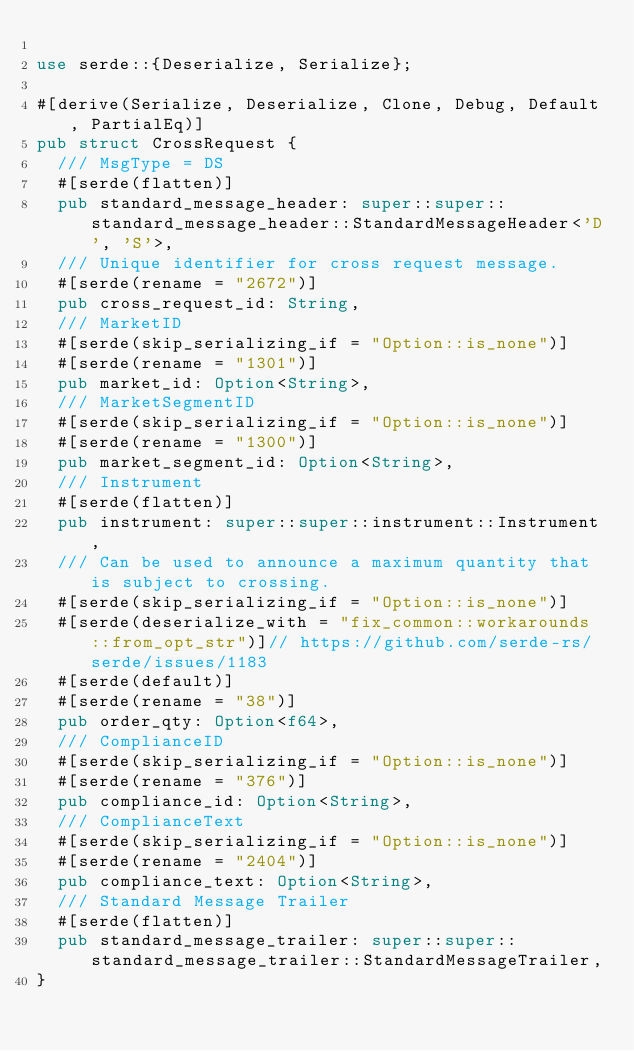Convert code to text. <code><loc_0><loc_0><loc_500><loc_500><_Rust_>
use serde::{Deserialize, Serialize};

#[derive(Serialize, Deserialize, Clone, Debug, Default, PartialEq)]
pub struct CrossRequest {
	/// MsgType = DS
	#[serde(flatten)]
	pub standard_message_header: super::super::standard_message_header::StandardMessageHeader<'D', 'S'>,
	/// Unique identifier for cross request message.
	#[serde(rename = "2672")]
	pub cross_request_id: String,
	/// MarketID
	#[serde(skip_serializing_if = "Option::is_none")]
	#[serde(rename = "1301")]
	pub market_id: Option<String>,
	/// MarketSegmentID
	#[serde(skip_serializing_if = "Option::is_none")]
	#[serde(rename = "1300")]
	pub market_segment_id: Option<String>,
	/// Instrument
	#[serde(flatten)]
	pub instrument: super::super::instrument::Instrument,
	/// Can be used to announce a maximum quantity that is subject to crossing.
	#[serde(skip_serializing_if = "Option::is_none")]
	#[serde(deserialize_with = "fix_common::workarounds::from_opt_str")]// https://github.com/serde-rs/serde/issues/1183
	#[serde(default)]
	#[serde(rename = "38")]
	pub order_qty: Option<f64>,
	/// ComplianceID
	#[serde(skip_serializing_if = "Option::is_none")]
	#[serde(rename = "376")]
	pub compliance_id: Option<String>,
	/// ComplianceText
	#[serde(skip_serializing_if = "Option::is_none")]
	#[serde(rename = "2404")]
	pub compliance_text: Option<String>,
	/// Standard Message Trailer
	#[serde(flatten)]
	pub standard_message_trailer: super::super::standard_message_trailer::StandardMessageTrailer,
}
</code> 